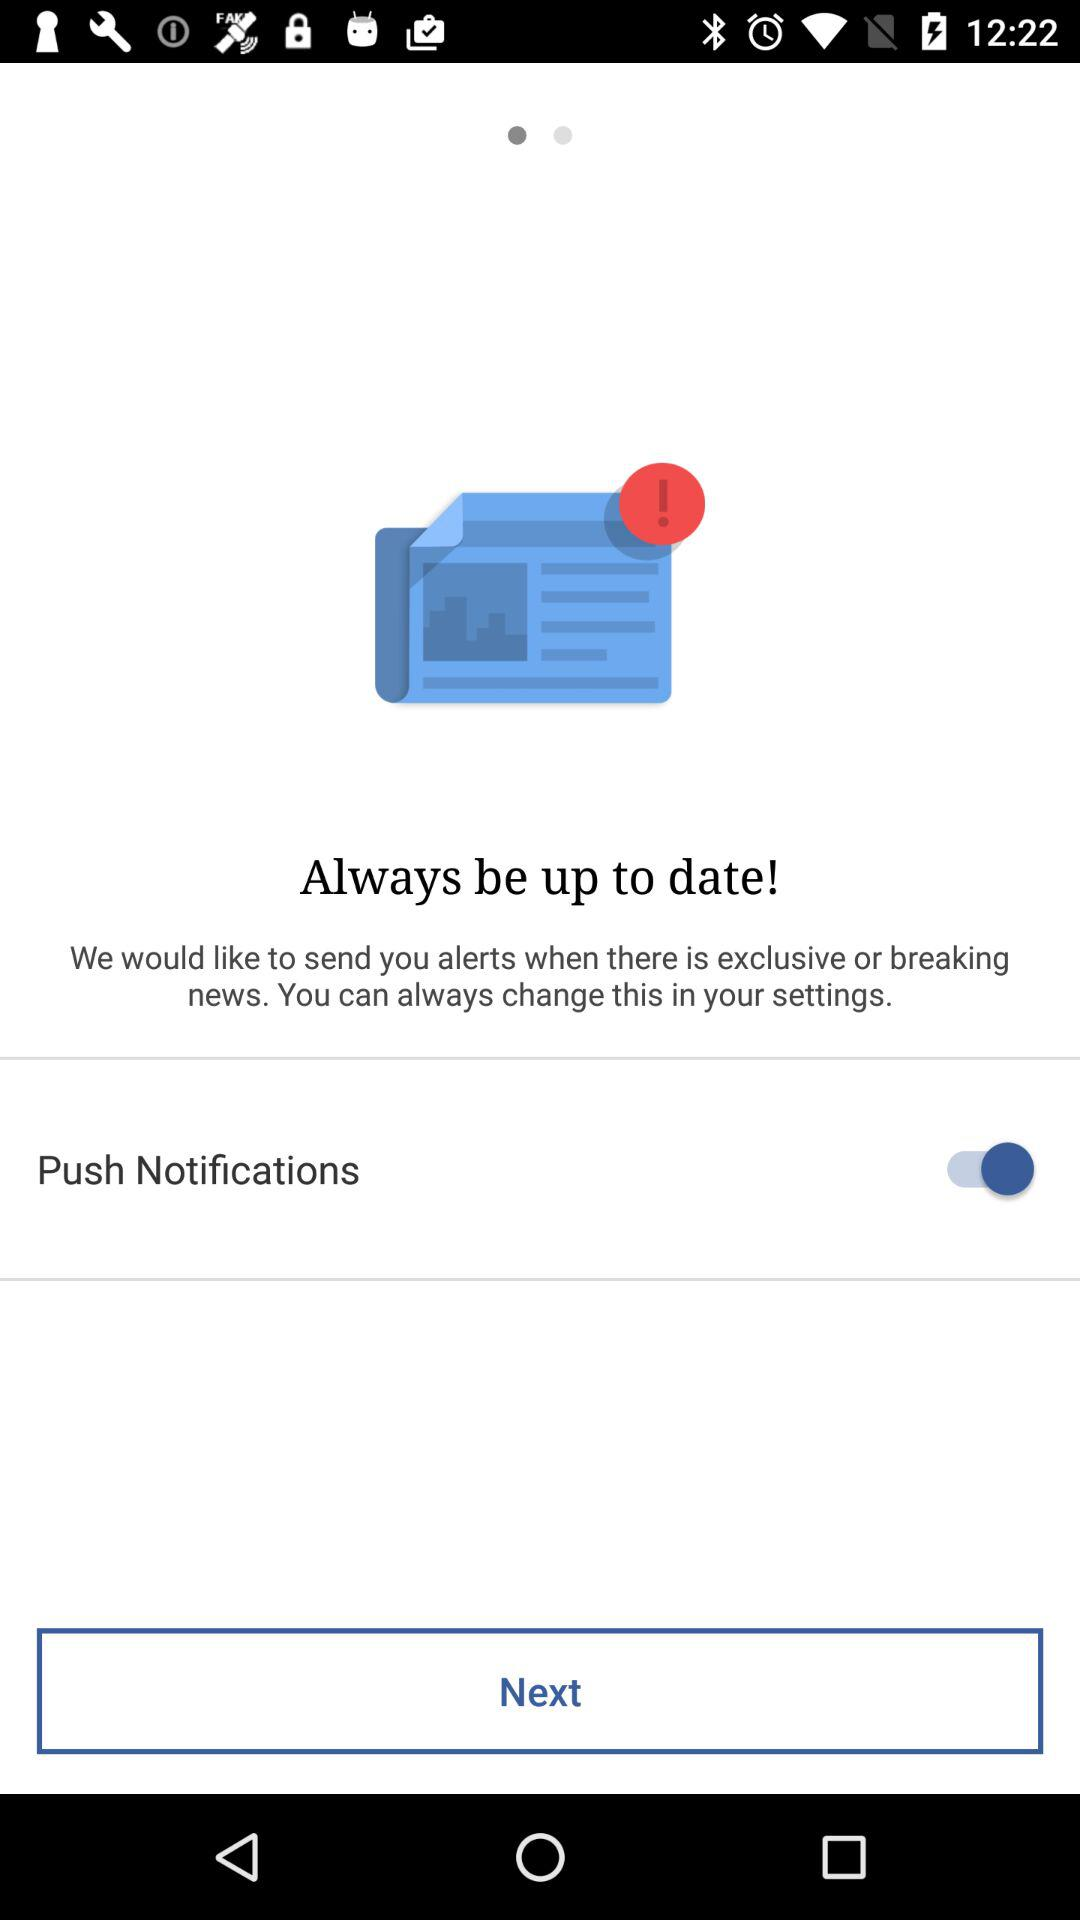What is the status of "Push Notifications"? The status is "on". 